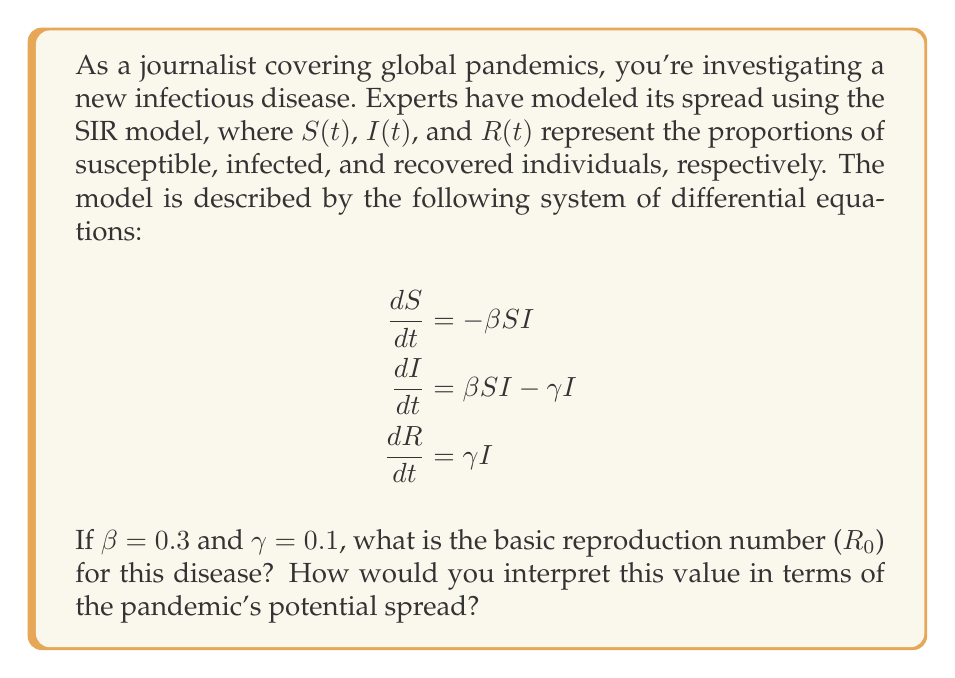Teach me how to tackle this problem. To solve this problem, we need to follow these steps:

1) The basic reproduction number ($R_0$) is a key parameter in epidemiology. It represents the average number of secondary infections caused by one infected individual in a completely susceptible population.

2) For the SIR model, $R_0$ is given by the formula:

   $$R_0 = \frac{\beta}{\gamma}$$

   where $\beta$ is the infection rate and $\gamma$ is the recovery rate.

3) We are given that $\beta = 0.3$ and $\gamma = 0.1$. Let's substitute these values:

   $$R_0 = \frac{0.3}{0.1} = 3$$

4) Interpretation:
   - If $R_0 > 1$, the disease will spread exponentially in the population.
   - If $R_0 < 1$, the disease will eventually die out.
   - If $R_0 = 1$, the disease will become endemic.

5) In this case, $R_0 = 3$, which is greater than 1. This means that, on average, each infected person will infect 3 others during their infectious period.

6) This value suggests that the disease has the potential to spread rapidly through the population, leading to an epidemic if no control measures are implemented.
Answer: $R_0 = 3$; indicates rapid spread potential 